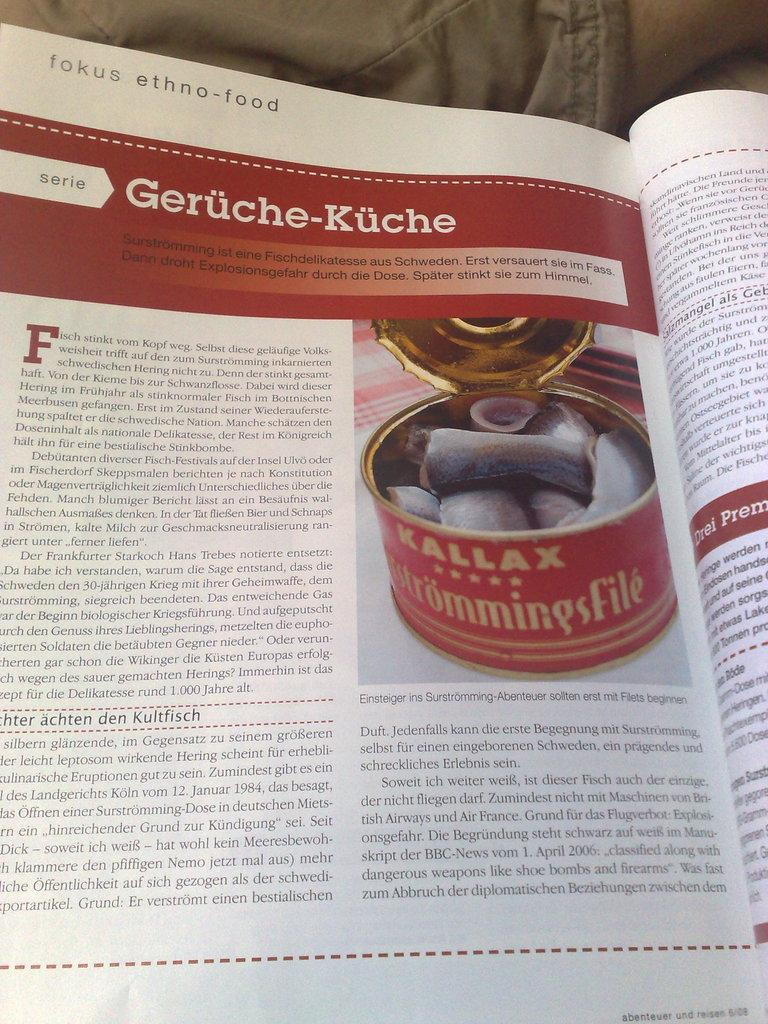<image>
Summarize the visual content of the image. the word geruche kuche that is on a magazine 